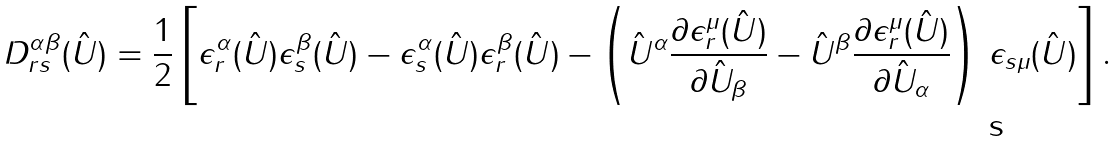<formula> <loc_0><loc_0><loc_500><loc_500>D ^ { \alpha \beta } _ { r s } ( \hat { U } ) = \frac { 1 } { 2 } \left [ \epsilon ^ { \alpha } _ { r } ( \hat { U } ) \epsilon ^ { \beta } _ { s } ( \hat { U } ) - \epsilon ^ { \alpha } _ { s } ( \hat { U } ) \epsilon ^ { \beta } _ { r } ( \hat { U } ) - \left ( { \hat { U } } ^ { \alpha } \frac { \partial \epsilon ^ { \mu } _ { r } ( \hat { U } ) } { \partial { \hat { U } } _ { \beta } } - { \hat { U } } ^ { \beta } \frac { \partial \epsilon ^ { \mu } _ { r } ( \hat { U } ) } { \partial { \hat { U } } _ { \alpha } } \right ) \, \epsilon _ { s \mu } ( \hat { U } ) \right ] .</formula> 